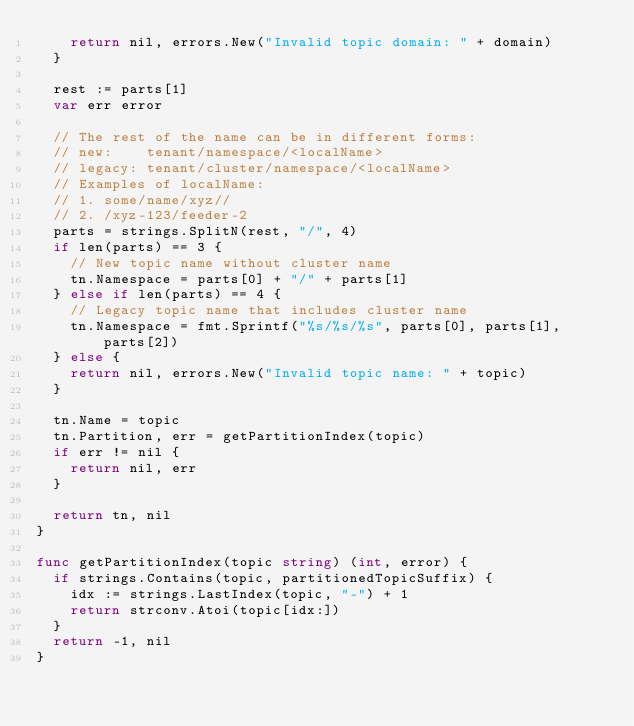<code> <loc_0><loc_0><loc_500><loc_500><_Go_>		return nil, errors.New("Invalid topic domain: " + domain)
	}

	rest := parts[1]
	var err error

	// The rest of the name can be in different forms:
	// new:    tenant/namespace/<localName>
	// legacy: tenant/cluster/namespace/<localName>
	// Examples of localName:
	// 1. some/name/xyz//
	// 2. /xyz-123/feeder-2
	parts = strings.SplitN(rest, "/", 4)
	if len(parts) == 3 {
		// New topic name without cluster name
		tn.Namespace = parts[0] + "/" + parts[1]
	} else if len(parts) == 4 {
		// Legacy topic name that includes cluster name
		tn.Namespace = fmt.Sprintf("%s/%s/%s", parts[0], parts[1], parts[2])
	} else {
		return nil, errors.New("Invalid topic name: " + topic)
	}

	tn.Name = topic
	tn.Partition, err = getPartitionIndex(topic)
	if err != nil {
		return nil, err
	}

	return tn, nil
}

func getPartitionIndex(topic string) (int, error) {
	if strings.Contains(topic, partitionedTopicSuffix) {
		idx := strings.LastIndex(topic, "-") + 1
		return strconv.Atoi(topic[idx:])
	}
	return -1, nil
}
</code> 